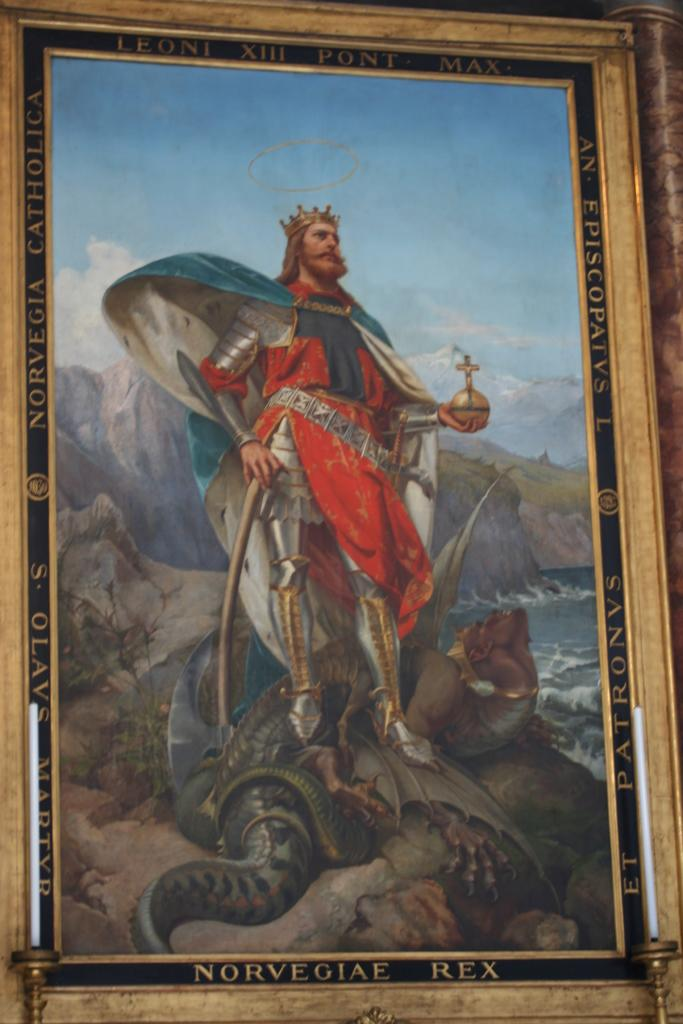What is the main object in the image that has a frame? There is a picture with a frame in the image. What is placed in front of the framed object? There are candles in front of the frame. What is the man in the image doing? A man is holding objects in the image. Can you describe the natural environment in the image? There is water visible in the image, and the sky is cloudy. What type of milk is being poured into the pig's bowl in the image? There is no milk or pig present in the image. 